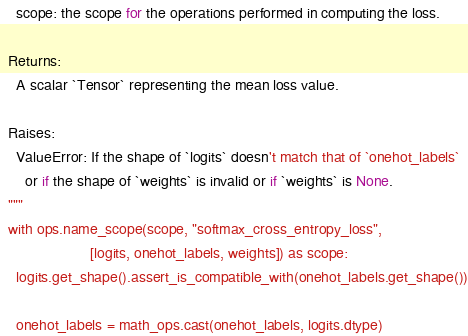<code> <loc_0><loc_0><loc_500><loc_500><_Python_>    scope: the scope for the operations performed in computing the loss.

  Returns:
    A scalar `Tensor` representing the mean loss value.

  Raises:
    ValueError: If the shape of `logits` doesn't match that of `onehot_labels`
      or if the shape of `weights` is invalid or if `weights` is None.
  """
  with ops.name_scope(scope, "softmax_cross_entropy_loss",
                      [logits, onehot_labels, weights]) as scope:
    logits.get_shape().assert_is_compatible_with(onehot_labels.get_shape())

    onehot_labels = math_ops.cast(onehot_labels, logits.dtype)
</code> 